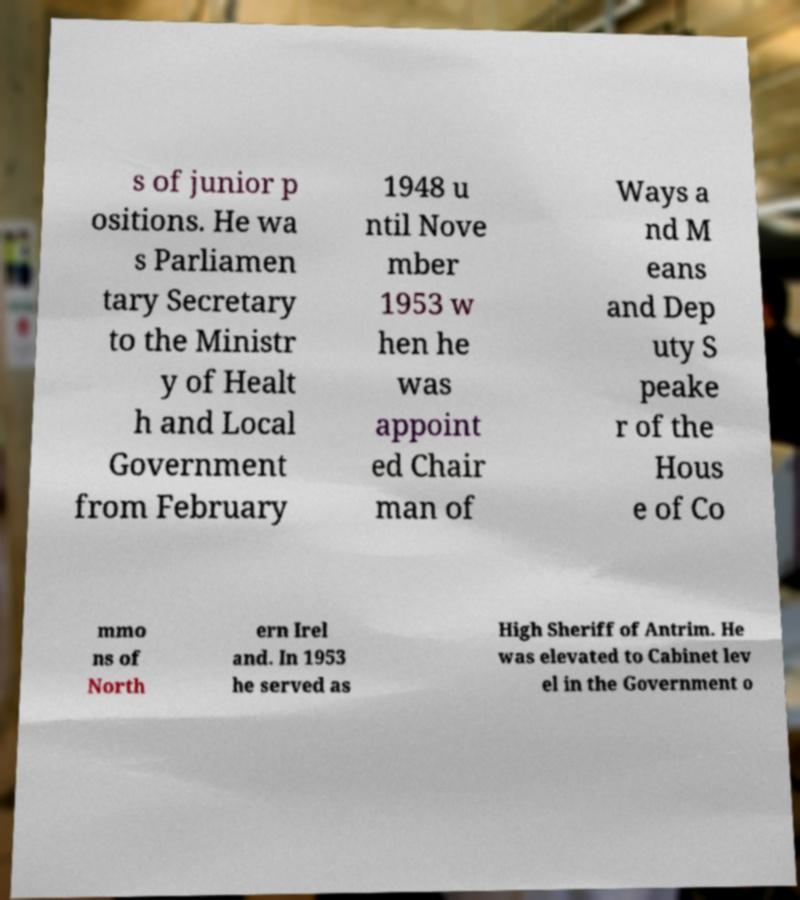Could you extract and type out the text from this image? s of junior p ositions. He wa s Parliamen tary Secretary to the Ministr y of Healt h and Local Government from February 1948 u ntil Nove mber 1953 w hen he was appoint ed Chair man of Ways a nd M eans and Dep uty S peake r of the Hous e of Co mmo ns of North ern Irel and. In 1953 he served as High Sheriff of Antrim. He was elevated to Cabinet lev el in the Government o 